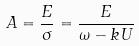Convert formula to latex. <formula><loc_0><loc_0><loc_500><loc_500>A = \frac { E } { \sigma } = \frac { E } { \omega - k U }</formula> 